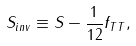<formula> <loc_0><loc_0><loc_500><loc_500>S _ { i n v } \equiv S - \frac { 1 } { 1 2 } f _ { T T } ,</formula> 